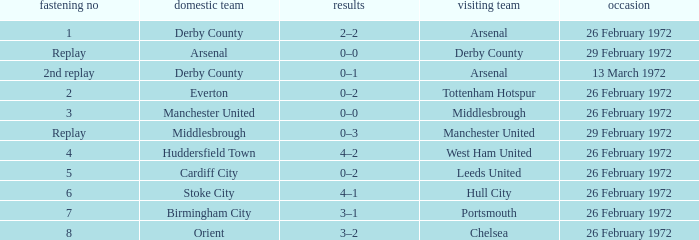Which Tie is from everton? 2.0. 